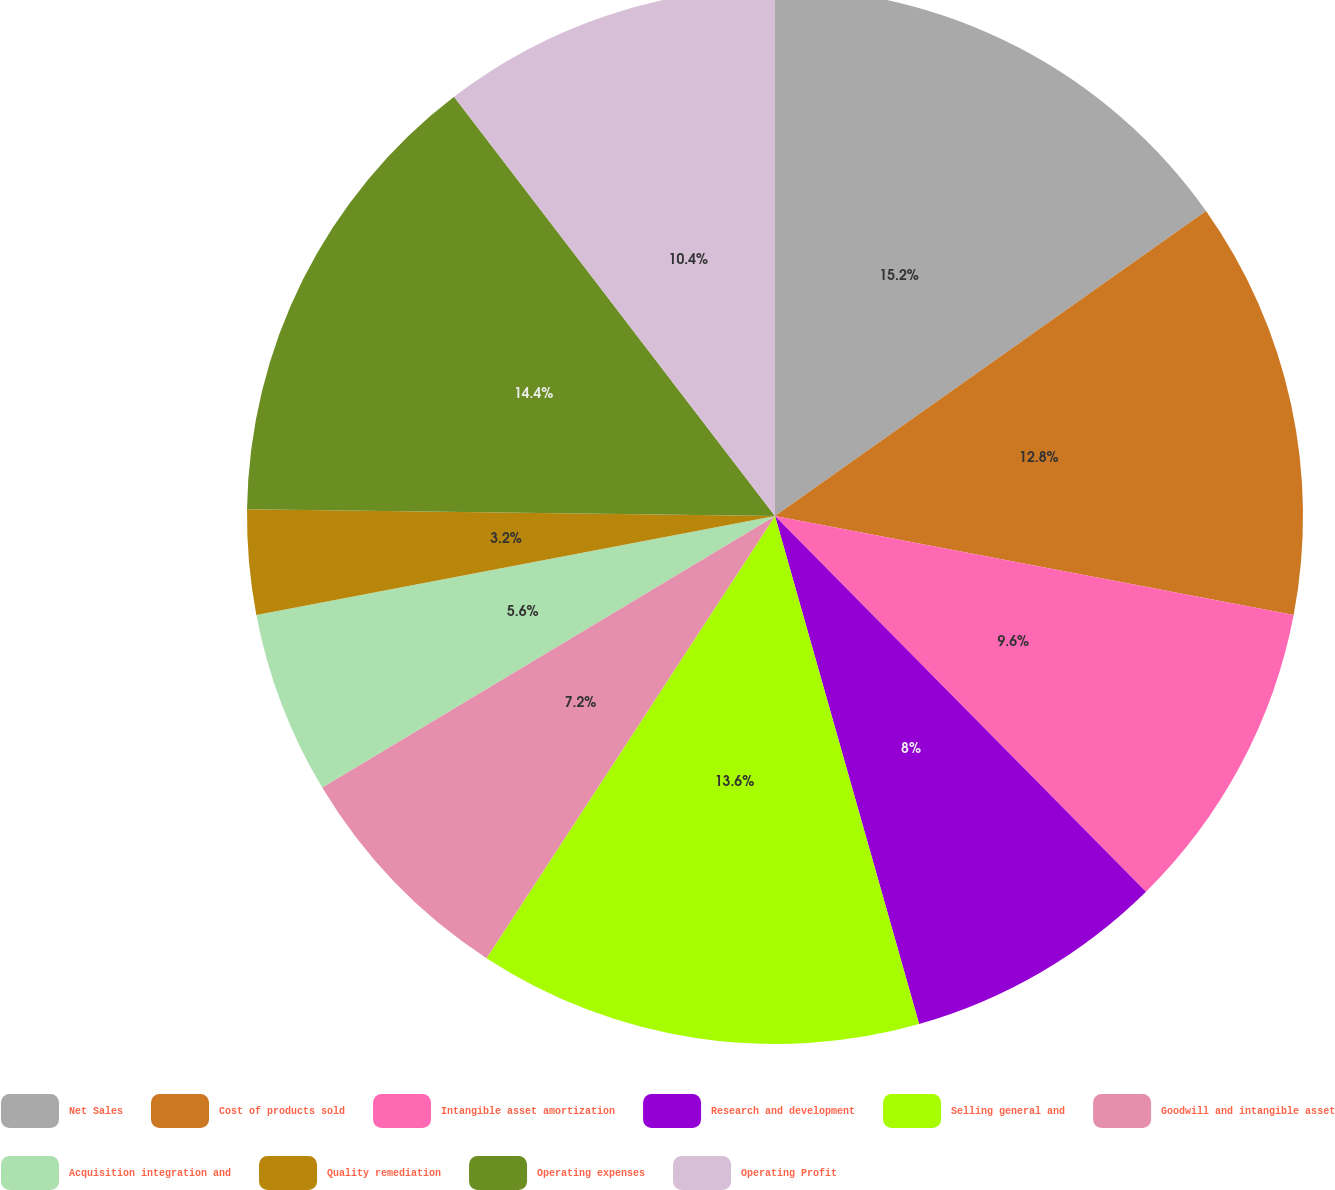Convert chart to OTSL. <chart><loc_0><loc_0><loc_500><loc_500><pie_chart><fcel>Net Sales<fcel>Cost of products sold<fcel>Intangible asset amortization<fcel>Research and development<fcel>Selling general and<fcel>Goodwill and intangible asset<fcel>Acquisition integration and<fcel>Quality remediation<fcel>Operating expenses<fcel>Operating Profit<nl><fcel>15.2%<fcel>12.8%<fcel>9.6%<fcel>8.0%<fcel>13.6%<fcel>7.2%<fcel>5.6%<fcel>3.2%<fcel>14.4%<fcel>10.4%<nl></chart> 